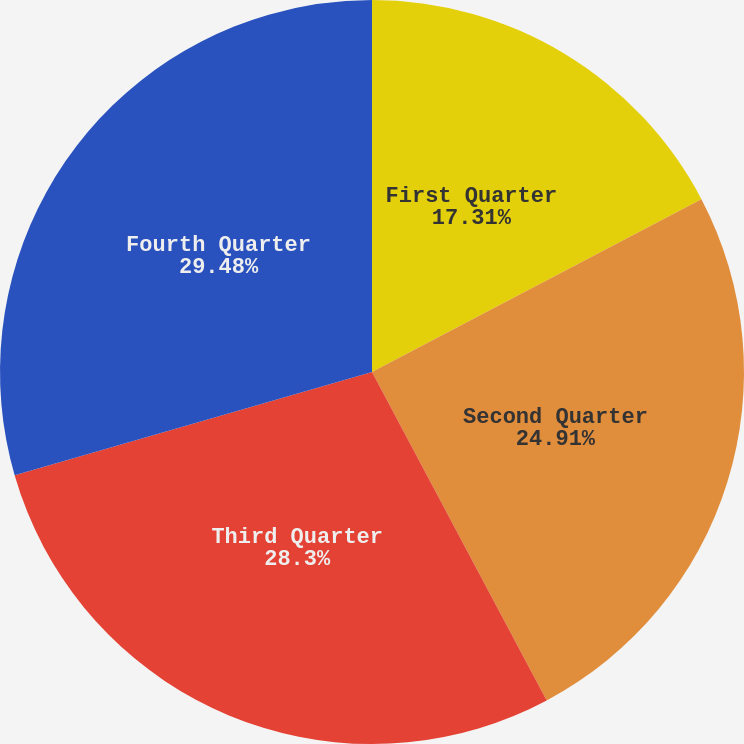Convert chart. <chart><loc_0><loc_0><loc_500><loc_500><pie_chart><fcel>First Quarter<fcel>Second Quarter<fcel>Third Quarter<fcel>Fourth Quarter<nl><fcel>17.31%<fcel>24.91%<fcel>28.3%<fcel>29.48%<nl></chart> 